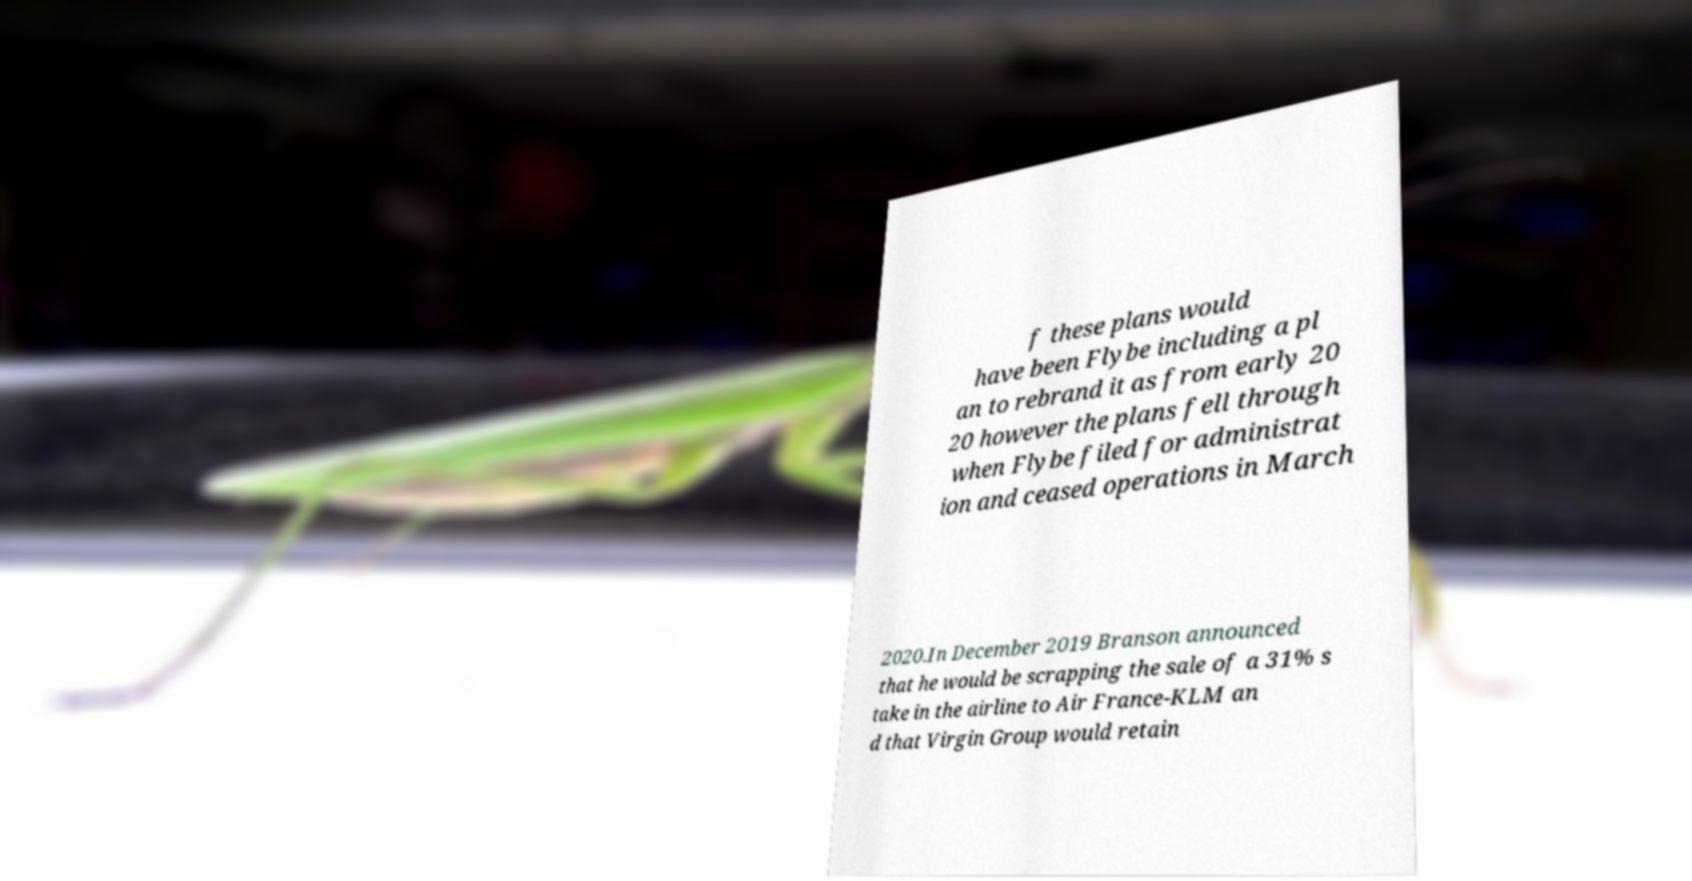There's text embedded in this image that I need extracted. Can you transcribe it verbatim? f these plans would have been Flybe including a pl an to rebrand it as from early 20 20 however the plans fell through when Flybe filed for administrat ion and ceased operations in March 2020.In December 2019 Branson announced that he would be scrapping the sale of a 31% s take in the airline to Air France-KLM an d that Virgin Group would retain 